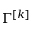Convert formula to latex. <formula><loc_0><loc_0><loc_500><loc_500>\Gamma ^ { [ k ] }</formula> 